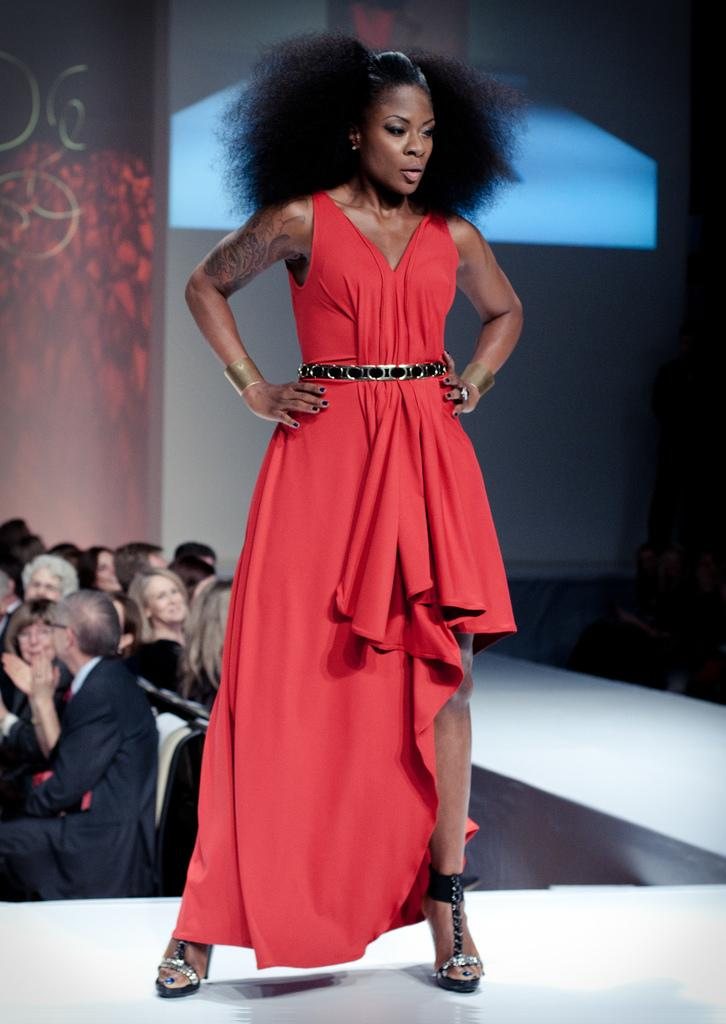What is the person in the image wearing? The person in the image is wearing clothes. Where is the person standing in the image? The person is standing on a ramp. Are there any other people visible in the image? Yes, there are other persons on the left side of the image. What type of disease is the person on the ramp suffering from in the image? There is no indication of any disease in the image; the person is simply standing on a ramp. 